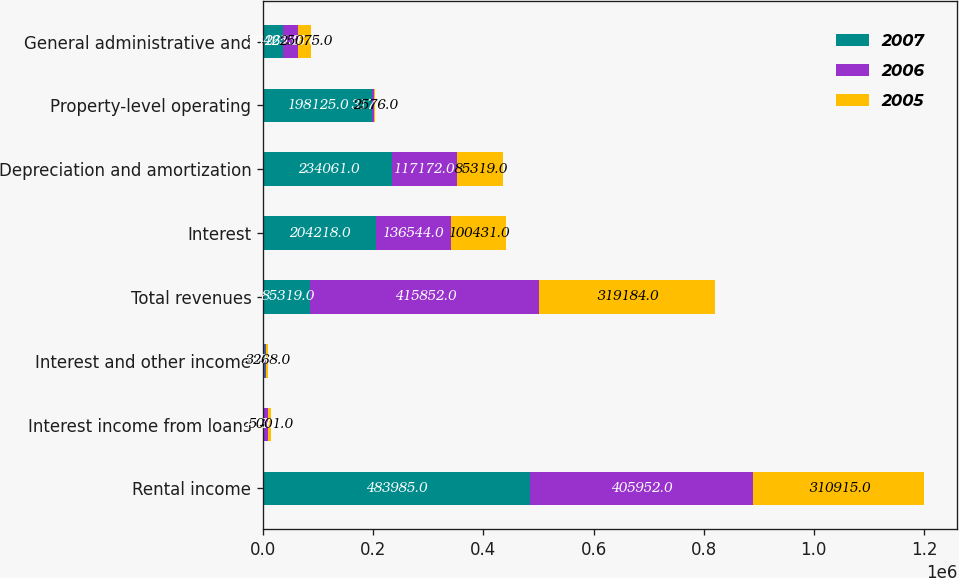<chart> <loc_0><loc_0><loc_500><loc_500><stacked_bar_chart><ecel><fcel>Rental income<fcel>Interest income from loans<fcel>Interest and other income<fcel>Total revenues<fcel>Interest<fcel>Depreciation and amortization<fcel>Property-level operating<fcel>General administrative and<nl><fcel>2007<fcel>483985<fcel>2586<fcel>2994<fcel>85319<fcel>204218<fcel>234061<fcel>198125<fcel>36425<nl><fcel>2006<fcel>405952<fcel>7014<fcel>2886<fcel>415852<fcel>136544<fcel>117172<fcel>3171<fcel>26136<nl><fcel>2005<fcel>310915<fcel>5001<fcel>3268<fcel>319184<fcel>100431<fcel>85319<fcel>2576<fcel>25075<nl></chart> 